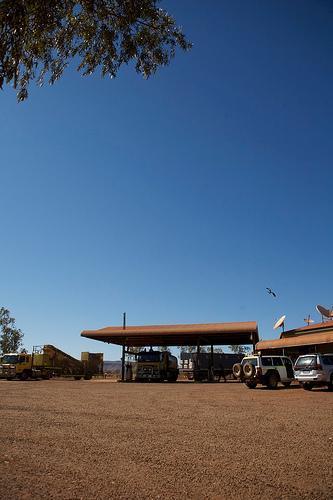How many cars are there?
Give a very brief answer. 2. 